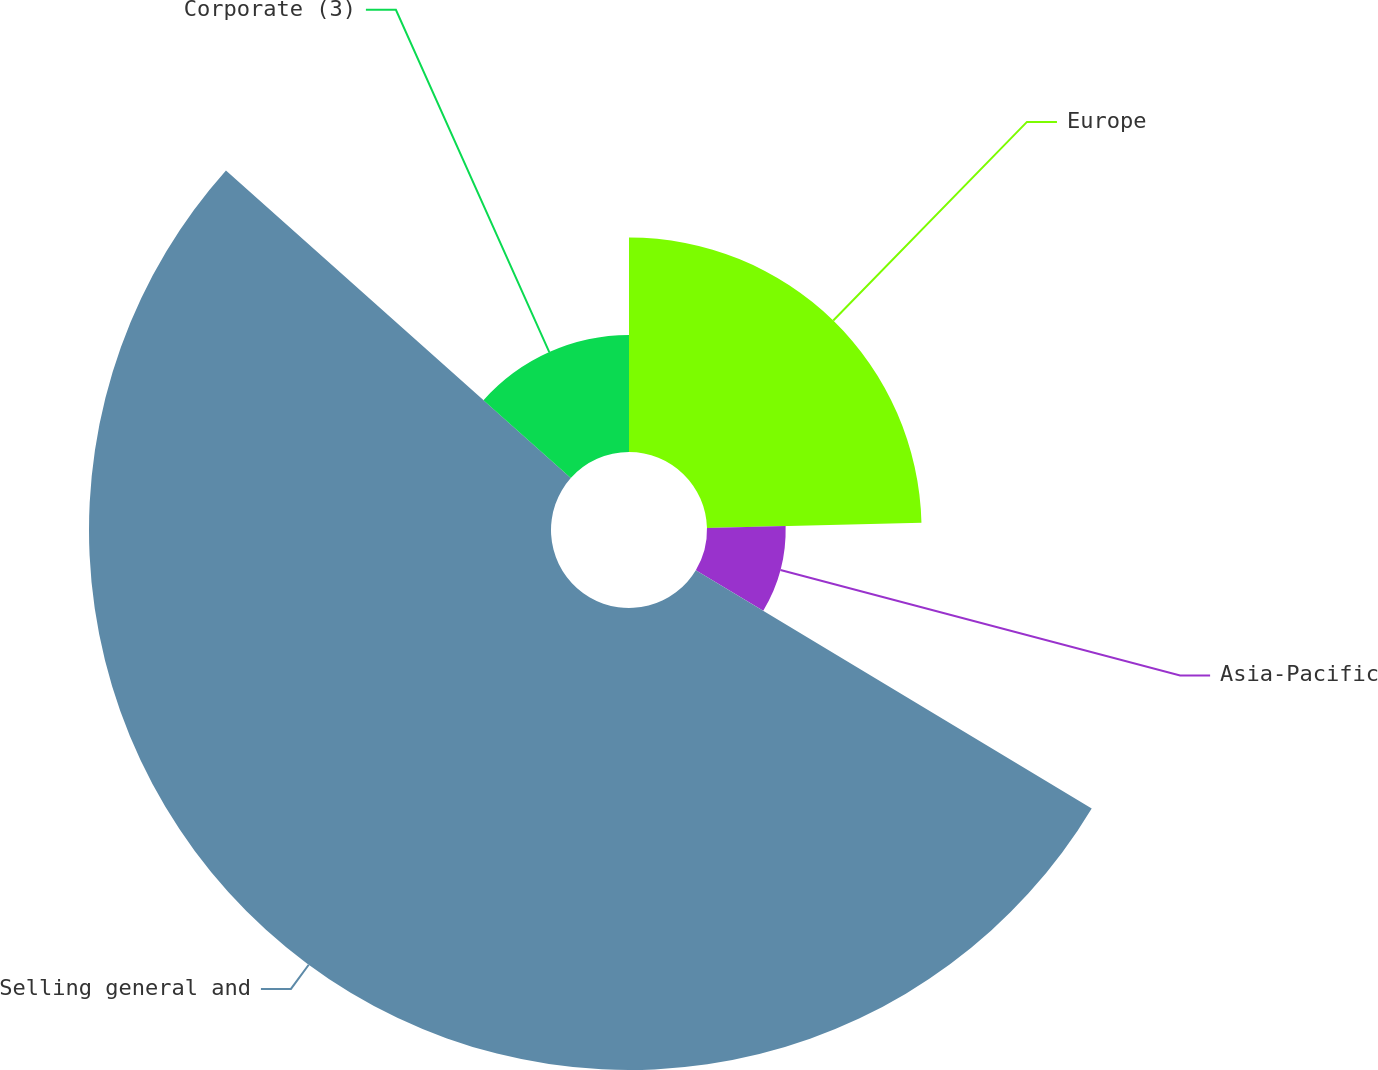Convert chart to OTSL. <chart><loc_0><loc_0><loc_500><loc_500><pie_chart><fcel>Europe<fcel>Asia-Pacific<fcel>Selling general and<fcel>Corporate (3)<nl><fcel>24.6%<fcel>9.02%<fcel>52.97%<fcel>13.41%<nl></chart> 